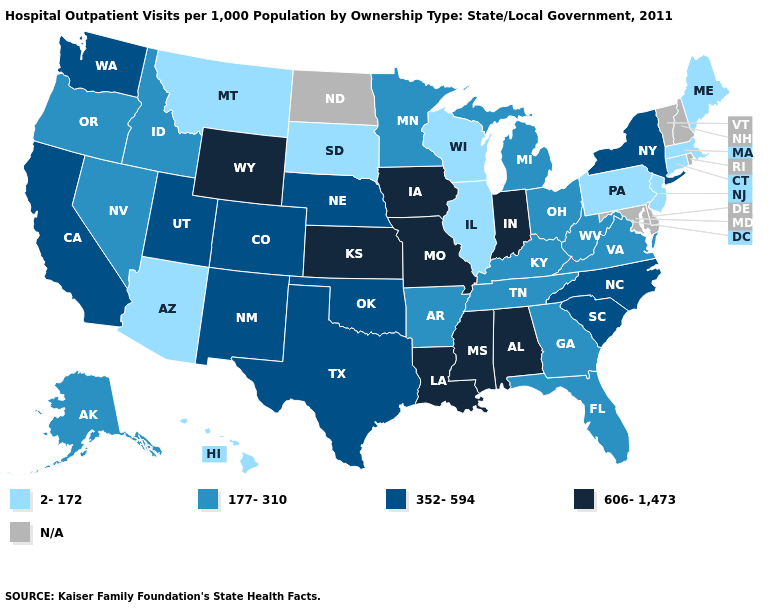What is the value of Kentucky?
Answer briefly. 177-310. What is the value of Delaware?
Answer briefly. N/A. Does Virginia have the highest value in the USA?
Concise answer only. No. Which states hav the highest value in the West?
Concise answer only. Wyoming. What is the value of Utah?
Quick response, please. 352-594. Which states have the highest value in the USA?
Keep it brief. Alabama, Indiana, Iowa, Kansas, Louisiana, Mississippi, Missouri, Wyoming. Name the states that have a value in the range N/A?
Be succinct. Delaware, Maryland, New Hampshire, North Dakota, Rhode Island, Vermont. Which states have the highest value in the USA?
Keep it brief. Alabama, Indiana, Iowa, Kansas, Louisiana, Mississippi, Missouri, Wyoming. What is the lowest value in the USA?
Be succinct. 2-172. Does the first symbol in the legend represent the smallest category?
Give a very brief answer. Yes. Name the states that have a value in the range 352-594?
Answer briefly. California, Colorado, Nebraska, New Mexico, New York, North Carolina, Oklahoma, South Carolina, Texas, Utah, Washington. What is the value of Oklahoma?
Write a very short answer. 352-594. Name the states that have a value in the range 606-1,473?
Short answer required. Alabama, Indiana, Iowa, Kansas, Louisiana, Mississippi, Missouri, Wyoming. Does Idaho have the lowest value in the West?
Answer briefly. No. 